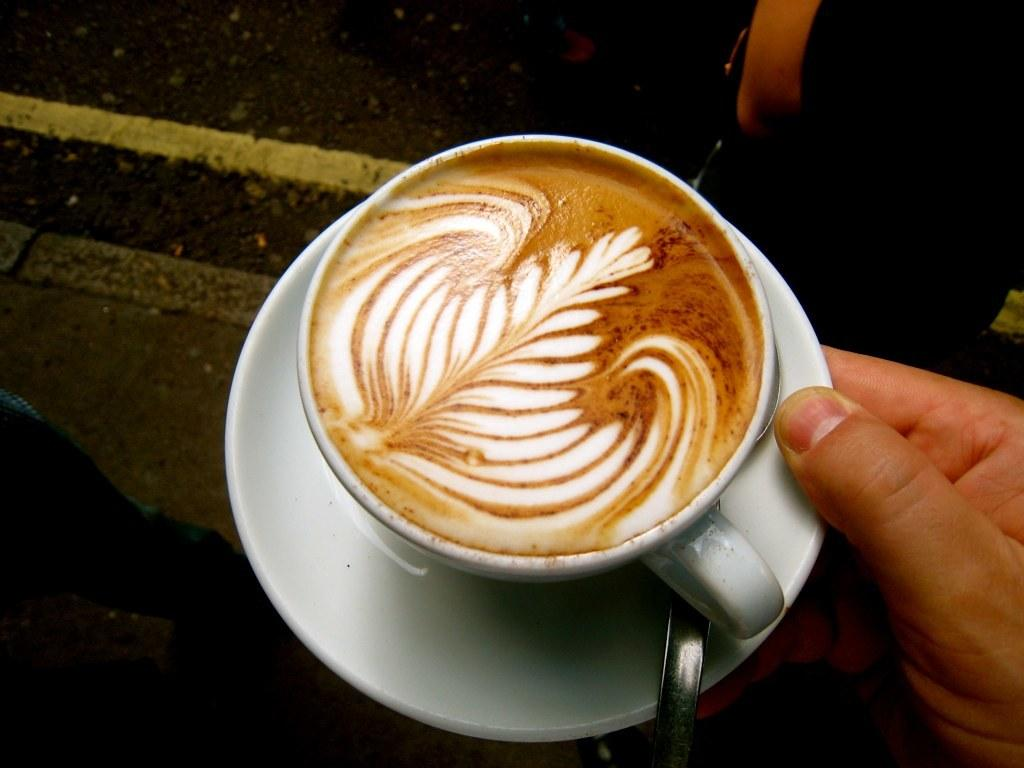What is in the cup that is visible in the image? There is a cup of coffee in the image. What is the cup resting on in the image? There is a saucer in the image. What utensil is present in the image? There is a spoon in the image. Who is holding the cup, saucer, and spoon in the image? A person is holding the cup, saucer, and spoon in the image. What type of boot can be seen floating in the waves in the image? There is no boot or waves present in the image; it features a cup of coffee, a saucer, a spoon, and a person holding them. 